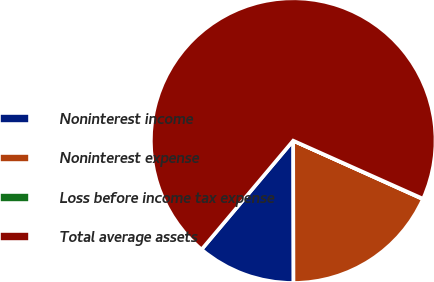Convert chart to OTSL. <chart><loc_0><loc_0><loc_500><loc_500><pie_chart><fcel>Noninterest income<fcel>Noninterest expense<fcel>Loss before income tax expense<fcel>Total average assets<nl><fcel>11.17%<fcel>18.22%<fcel>0.05%<fcel>70.56%<nl></chart> 